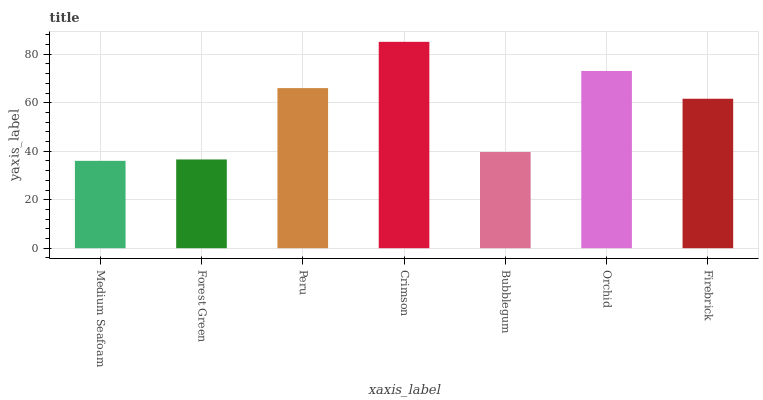Is Medium Seafoam the minimum?
Answer yes or no. Yes. Is Crimson the maximum?
Answer yes or no. Yes. Is Forest Green the minimum?
Answer yes or no. No. Is Forest Green the maximum?
Answer yes or no. No. Is Forest Green greater than Medium Seafoam?
Answer yes or no. Yes. Is Medium Seafoam less than Forest Green?
Answer yes or no. Yes. Is Medium Seafoam greater than Forest Green?
Answer yes or no. No. Is Forest Green less than Medium Seafoam?
Answer yes or no. No. Is Firebrick the high median?
Answer yes or no. Yes. Is Firebrick the low median?
Answer yes or no. Yes. Is Crimson the high median?
Answer yes or no. No. Is Forest Green the low median?
Answer yes or no. No. 